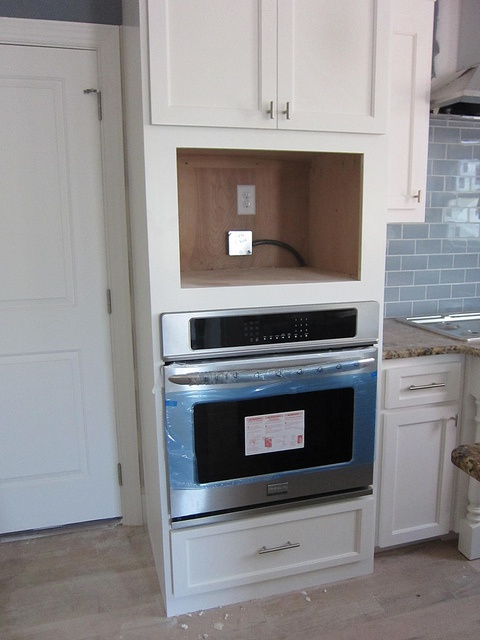Describe the objects in this image and their specific colors. I can see a oven in gray, black, and darkgray tones in this image. 